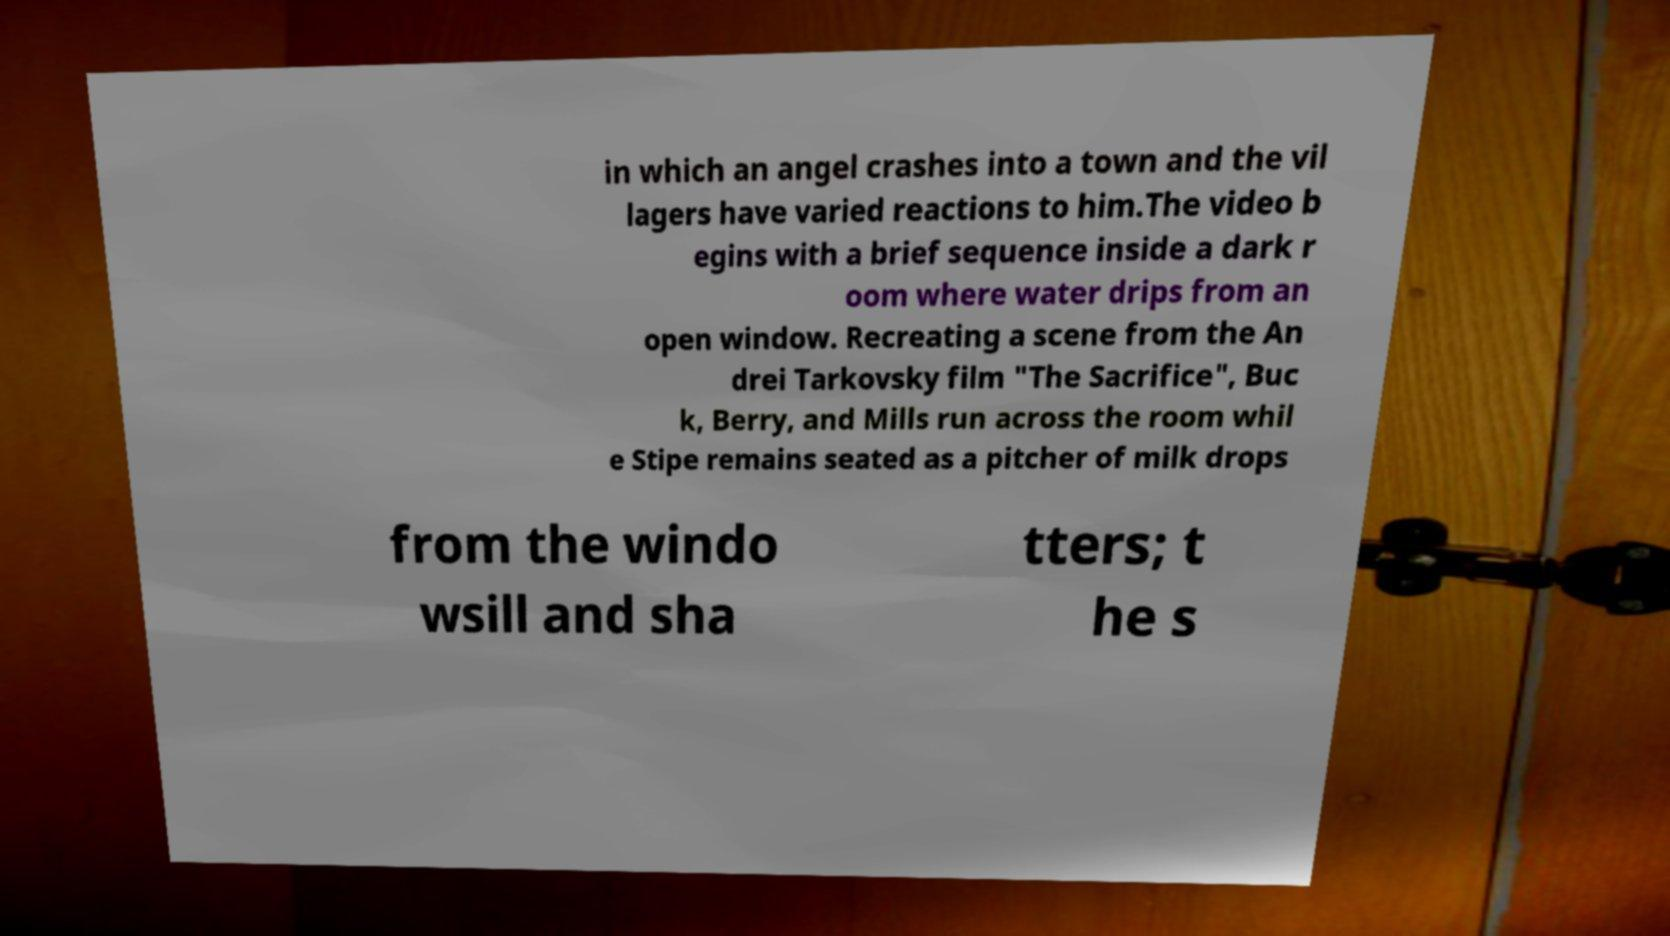Could you extract and type out the text from this image? in which an angel crashes into a town and the vil lagers have varied reactions to him.The video b egins with a brief sequence inside a dark r oom where water drips from an open window. Recreating a scene from the An drei Tarkovsky film "The Sacrifice", Buc k, Berry, and Mills run across the room whil e Stipe remains seated as a pitcher of milk drops from the windo wsill and sha tters; t he s 